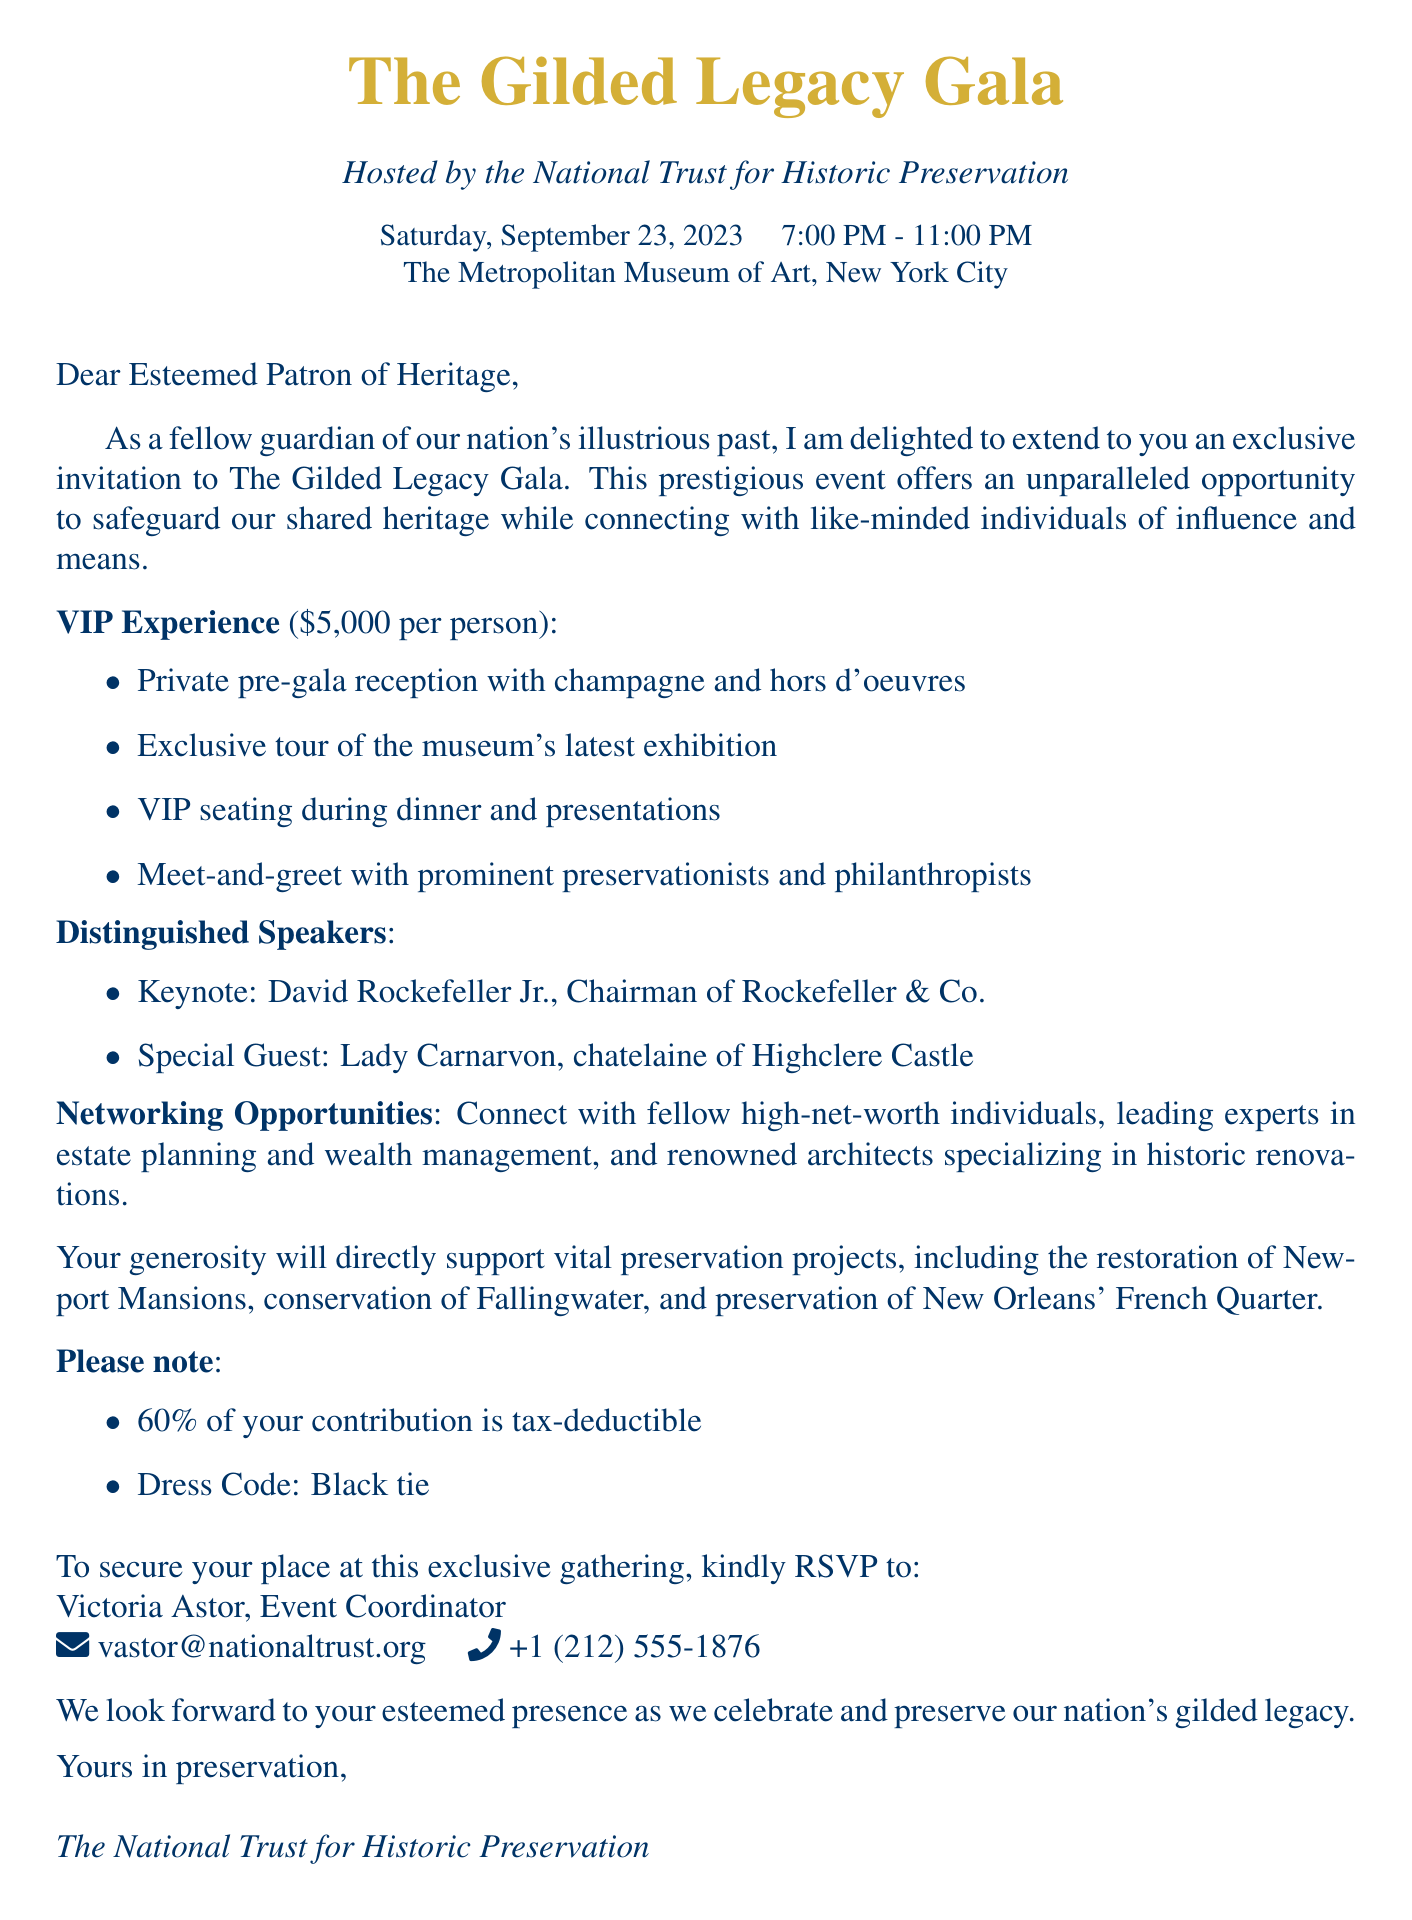What is the date of the gala? The date of the gala is explicitly mentioned in the document as "Saturday, September 23, 2023."
Answer: Saturday, September 23, 2023 What is the venue of the event? The venue for the event is stated in the document as "The Metropolitan Museum of Art, New York City."
Answer: The Metropolitan Museum of Art, New York City Who is the keynote speaker? The document identifies the keynote speaker as "David Rockefeller Jr., Chairman of Rockefeller & Co."
Answer: David Rockefeller Jr What is the ticket price? The ticket price is clearly stated in the document as "$5,000 per person."
Answer: $5,000 per person What percentage of the contribution is tax-deductible? The document mentions that "60% of your contribution is tax-deductible."
Answer: 60% What are some of the preservation projects supported by the gala? The document lists several preservation projects, stating specific projects like "Restoration of the Newport Mansions in Rhode Island."
Answer: Restoration of the Newport Mansions in Rhode Island What is included in the VIP perks? The document outlines VIP perks, including items such as "Private pre-gala reception with champagne and hors d'oeuvres."
Answer: Private pre-gala reception with champagne and hors d'oeuvres What is the dress code for the event? The dress code is specifically mentioned in the document as "Black tie."
Answer: Black tie Who should be contacted for RSVP? The document names "Victoria Astor, Event Coordinator" as the contact for RSVP.
Answer: Victoria Astor, Event Coordinator 